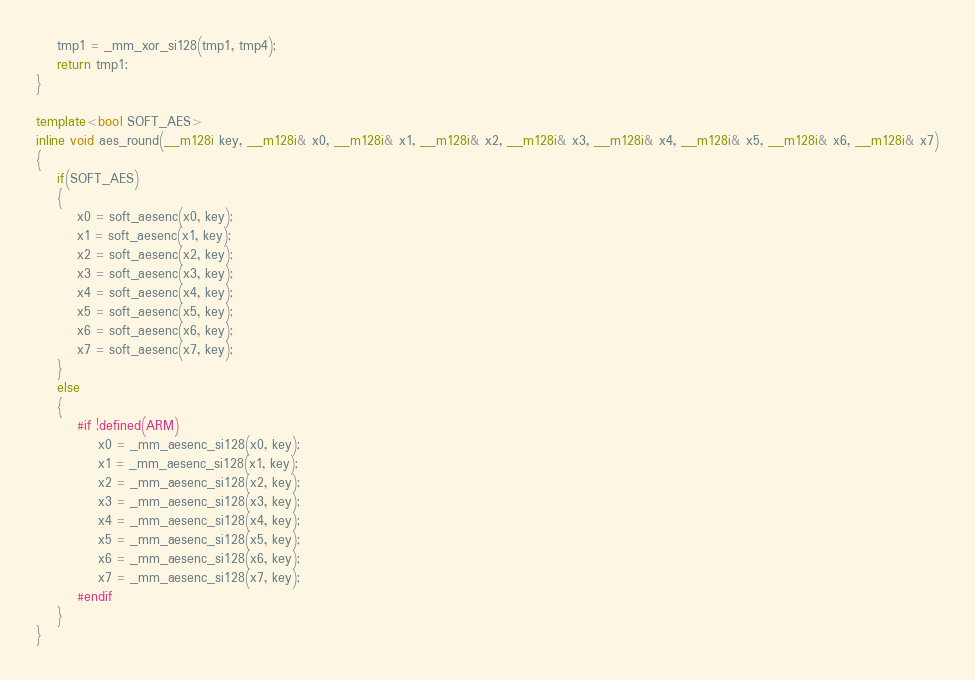<code> <loc_0><loc_0><loc_500><loc_500><_C++_>	tmp1 = _mm_xor_si128(tmp1, tmp4);
	return tmp1;
}

template<bool SOFT_AES>
inline void aes_round(__m128i key, __m128i& x0, __m128i& x1, __m128i& x2, __m128i& x3, __m128i& x4, __m128i& x5, __m128i& x6, __m128i& x7)
{
	if(SOFT_AES)
	{
		x0 = soft_aesenc(x0, key);
		x1 = soft_aesenc(x1, key);
		x2 = soft_aesenc(x2, key);
		x3 = soft_aesenc(x3, key);
		x4 = soft_aesenc(x4, key);
		x5 = soft_aesenc(x5, key);
		x6 = soft_aesenc(x6, key);
		x7 = soft_aesenc(x7, key);
	}
	else
	{
		#if !defined(ARM)
			x0 = _mm_aesenc_si128(x0, key);
			x1 = _mm_aesenc_si128(x1, key);
			x2 = _mm_aesenc_si128(x2, key);
			x3 = _mm_aesenc_si128(x3, key);
			x4 = _mm_aesenc_si128(x4, key);
			x5 = _mm_aesenc_si128(x5, key);
			x6 = _mm_aesenc_si128(x6, key);
			x7 = _mm_aesenc_si128(x7, key);
		#endif
	}
}
</code> 